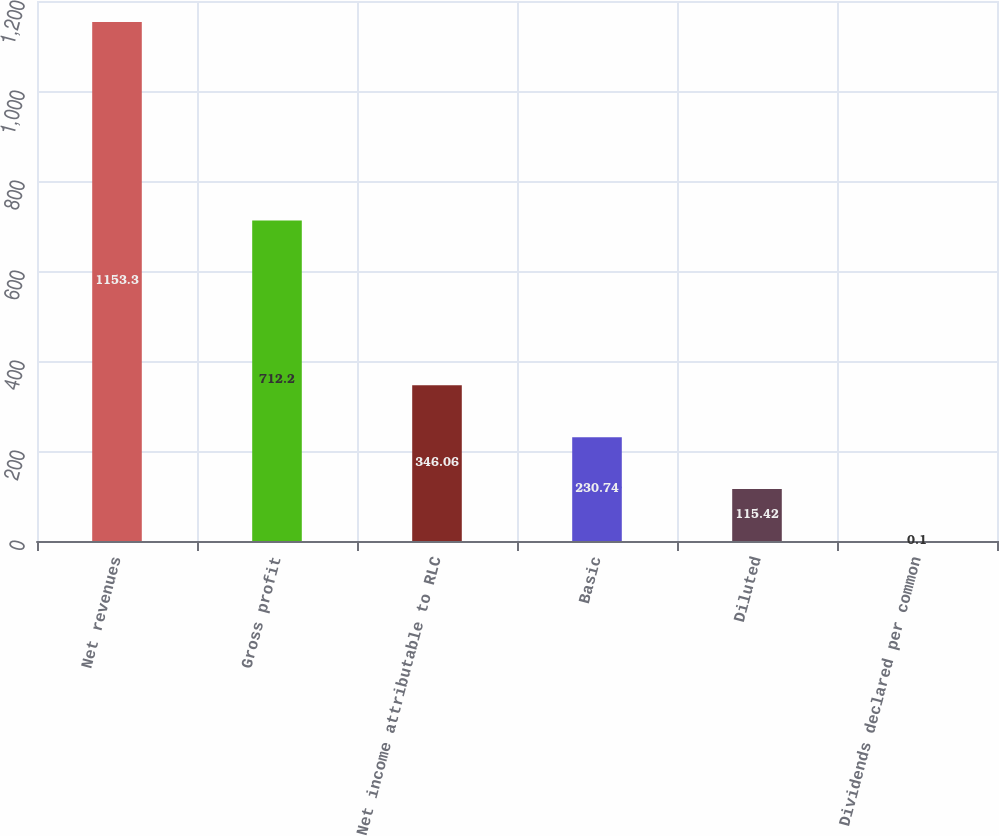Convert chart. <chart><loc_0><loc_0><loc_500><loc_500><bar_chart><fcel>Net revenues<fcel>Gross profit<fcel>Net income attributable to RLC<fcel>Basic<fcel>Diluted<fcel>Dividends declared per common<nl><fcel>1153.3<fcel>712.2<fcel>346.06<fcel>230.74<fcel>115.42<fcel>0.1<nl></chart> 